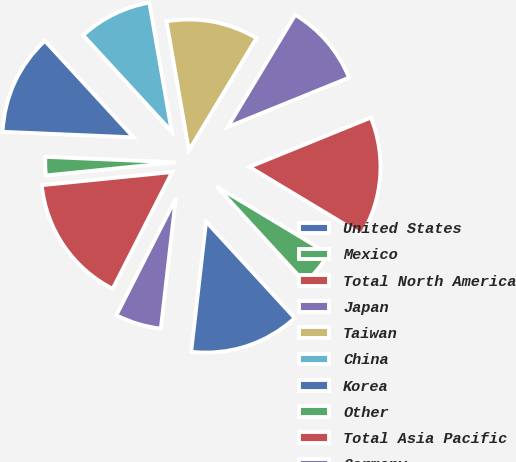<chart> <loc_0><loc_0><loc_500><loc_500><pie_chart><fcel>United States<fcel>Mexico<fcel>Total North America<fcel>Japan<fcel>Taiwan<fcel>China<fcel>Korea<fcel>Other<fcel>Total Asia Pacific<fcel>Germany<nl><fcel>13.64%<fcel>4.55%<fcel>14.77%<fcel>10.23%<fcel>11.36%<fcel>9.09%<fcel>12.5%<fcel>2.27%<fcel>15.91%<fcel>5.68%<nl></chart> 